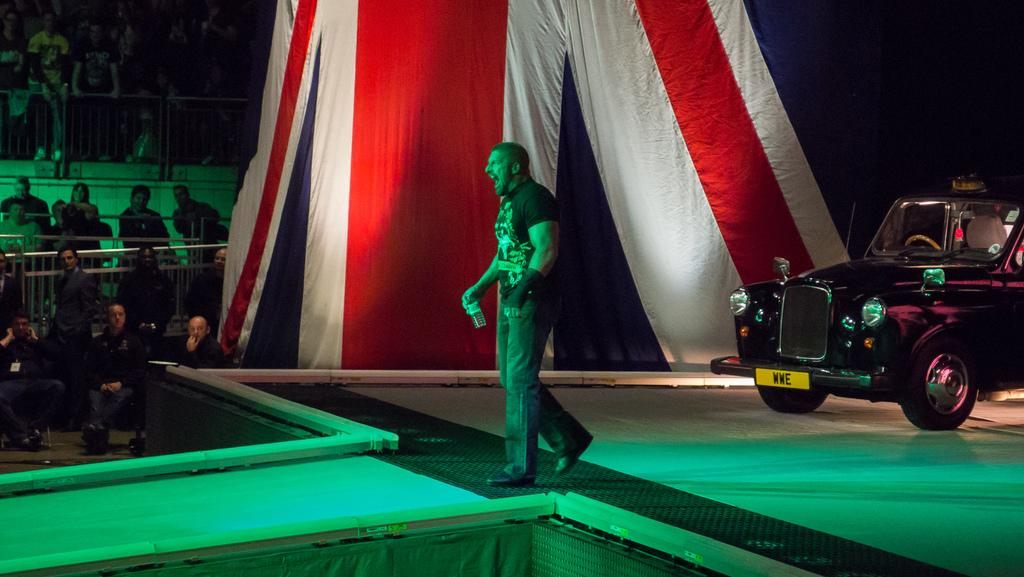What is the main subject of the image? There is a man in the image. What is the man doing in the image? The man is walking on a stage. What is the man holding in the image? The man is holding a bottle. What is located beside the man in the image? There is a car beside the man. What can be seen on the left side of the image? There is a group of people and a fence on the left side of the image. What time does the clock on the stage show in the image? There is no clock present in the image, so it is not possible to determine the time. 